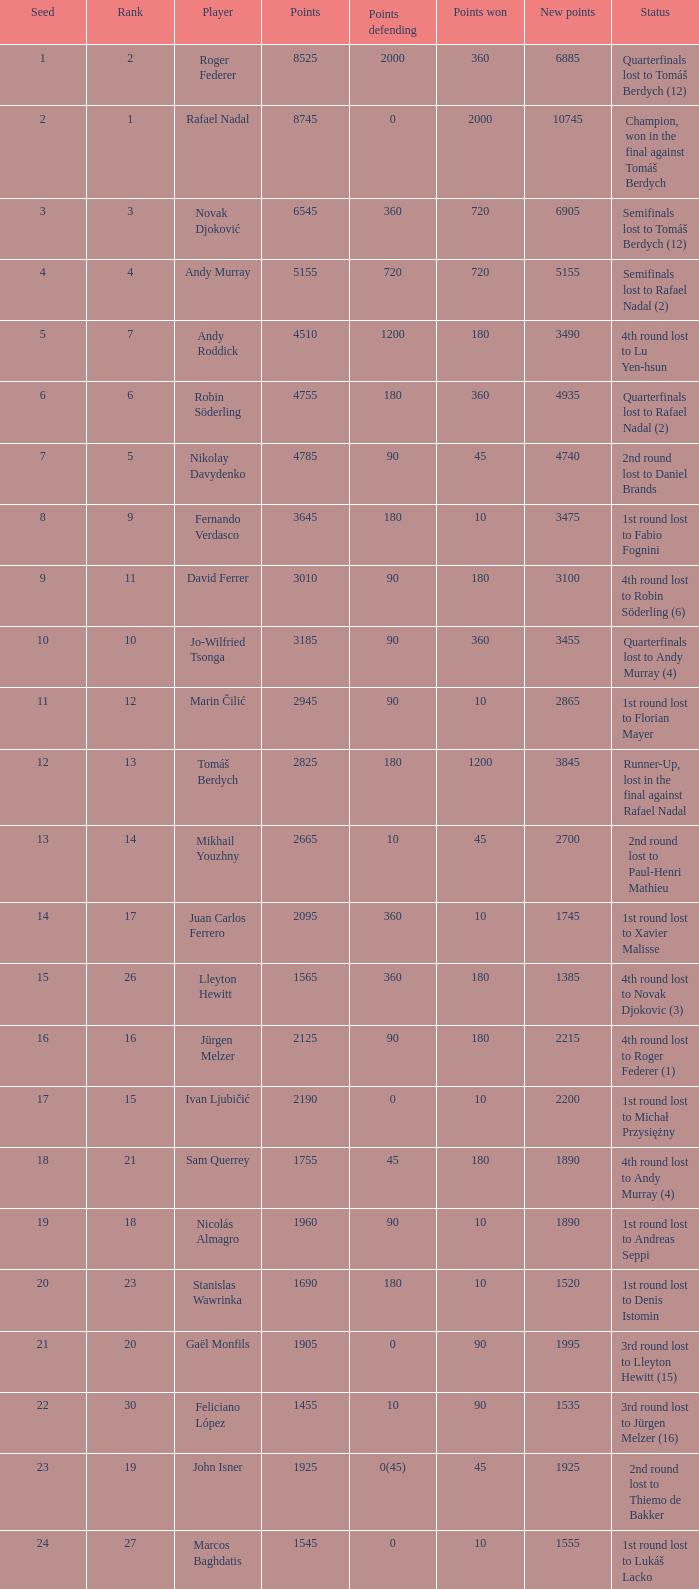Identify the minimum new points for points protection being 120 3490.0. Can you give me this table as a dict? {'header': ['Seed', 'Rank', 'Player', 'Points', 'Points defending', 'Points won', 'New points', 'Status'], 'rows': [['1', '2', 'Roger Federer', '8525', '2000', '360', '6885', 'Quarterfinals lost to Tomáš Berdych (12)'], ['2', '1', 'Rafael Nadal', '8745', '0', '2000', '10745', 'Champion, won in the final against Tomáš Berdych'], ['3', '3', 'Novak Djoković', '6545', '360', '720', '6905', 'Semifinals lost to Tomáš Berdych (12)'], ['4', '4', 'Andy Murray', '5155', '720', '720', '5155', 'Semifinals lost to Rafael Nadal (2)'], ['5', '7', 'Andy Roddick', '4510', '1200', '180', '3490', '4th round lost to Lu Yen-hsun'], ['6', '6', 'Robin Söderling', '4755', '180', '360', '4935', 'Quarterfinals lost to Rafael Nadal (2)'], ['7', '5', 'Nikolay Davydenko', '4785', '90', '45', '4740', '2nd round lost to Daniel Brands'], ['8', '9', 'Fernando Verdasco', '3645', '180', '10', '3475', '1st round lost to Fabio Fognini'], ['9', '11', 'David Ferrer', '3010', '90', '180', '3100', '4th round lost to Robin Söderling (6)'], ['10', '10', 'Jo-Wilfried Tsonga', '3185', '90', '360', '3455', 'Quarterfinals lost to Andy Murray (4)'], ['11', '12', 'Marin Čilić', '2945', '90', '10', '2865', '1st round lost to Florian Mayer'], ['12', '13', 'Tomáš Berdych', '2825', '180', '1200', '3845', 'Runner-Up, lost in the final against Rafael Nadal'], ['13', '14', 'Mikhail Youzhny', '2665', '10', '45', '2700', '2nd round lost to Paul-Henri Mathieu'], ['14', '17', 'Juan Carlos Ferrero', '2095', '360', '10', '1745', '1st round lost to Xavier Malisse'], ['15', '26', 'Lleyton Hewitt', '1565', '360', '180', '1385', '4th round lost to Novak Djokovic (3)'], ['16', '16', 'Jürgen Melzer', '2125', '90', '180', '2215', '4th round lost to Roger Federer (1)'], ['17', '15', 'Ivan Ljubičić', '2190', '0', '10', '2200', '1st round lost to Michał Przysiężny'], ['18', '21', 'Sam Querrey', '1755', '45', '180', '1890', '4th round lost to Andy Murray (4)'], ['19', '18', 'Nicolás Almagro', '1960', '90', '10', '1890', '1st round lost to Andreas Seppi'], ['20', '23', 'Stanislas Wawrinka', '1690', '180', '10', '1520', '1st round lost to Denis Istomin'], ['21', '20', 'Gaël Monfils', '1905', '0', '90', '1995', '3rd round lost to Lleyton Hewitt (15)'], ['22', '30', 'Feliciano López', '1455', '10', '90', '1535', '3rd round lost to Jürgen Melzer (16)'], ['23', '19', 'John Isner', '1925', '0(45)', '45', '1925', '2nd round lost to Thiemo de Bakker'], ['24', '27', 'Marcos Baghdatis', '1545', '0', '10', '1555', '1st round lost to Lukáš Lacko'], ['25', '24', 'Thomaz Bellucci', '1652', '0(20)', '90', '1722', '3rd round lost to Robin Söderling (6)'], ['26', '32', 'Gilles Simon', '1305', '180', '90', '1215', '3rd round lost to Andy Murray (4)'], ['28', '31', 'Albert Montañés', '1405', '90', '90', '1405', '3rd round lost to Novak Djokovic (3)'], ['29', '35', 'Philipp Kohlschreiber', '1230', '90', '90', '1230', '3rd round lost to Andy Roddick (5)'], ['30', '36', 'Tommy Robredo', '1155', '90', '10', '1075', '1st round lost to Peter Luczak'], ['31', '37', 'Victor Hănescu', '1070', '45', '90', '1115', '3rd round lost to Daniel Brands'], ['32', '38', 'Julien Benneteau', '1059', '10', '180', '1229', '4th round lost to Jo-Wilfried Tsonga (10)']]} 